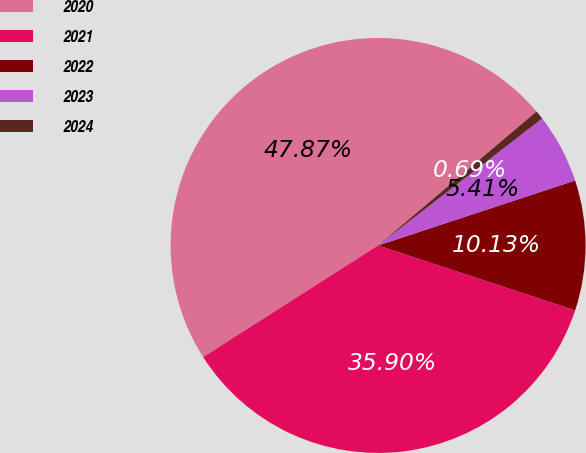Convert chart. <chart><loc_0><loc_0><loc_500><loc_500><pie_chart><fcel>2020<fcel>2021<fcel>2022<fcel>2023<fcel>2024<nl><fcel>47.87%<fcel>35.9%<fcel>10.13%<fcel>5.41%<fcel>0.69%<nl></chart> 